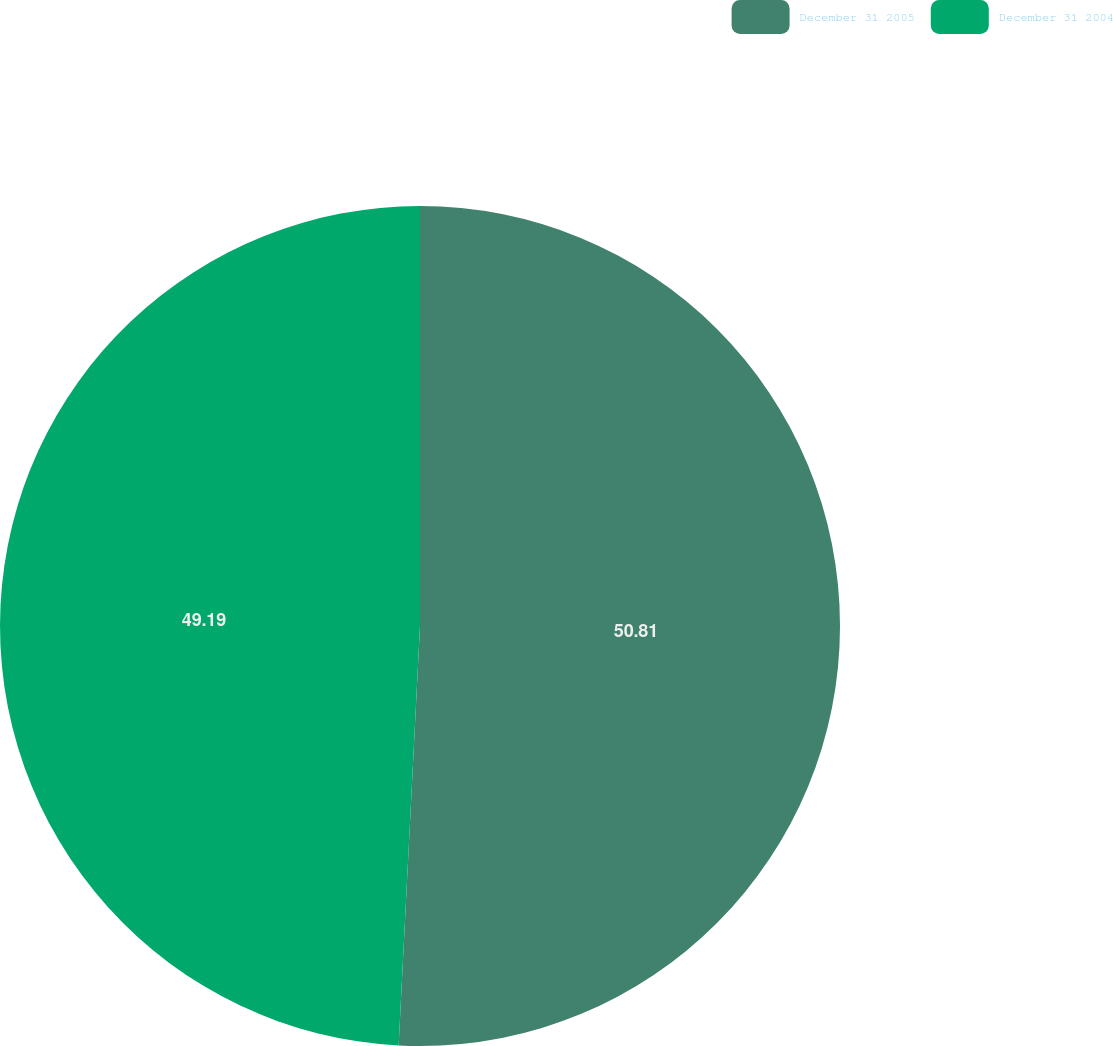Convert chart. <chart><loc_0><loc_0><loc_500><loc_500><pie_chart><fcel>December 31 2005<fcel>December 31 2004<nl><fcel>50.81%<fcel>49.19%<nl></chart> 